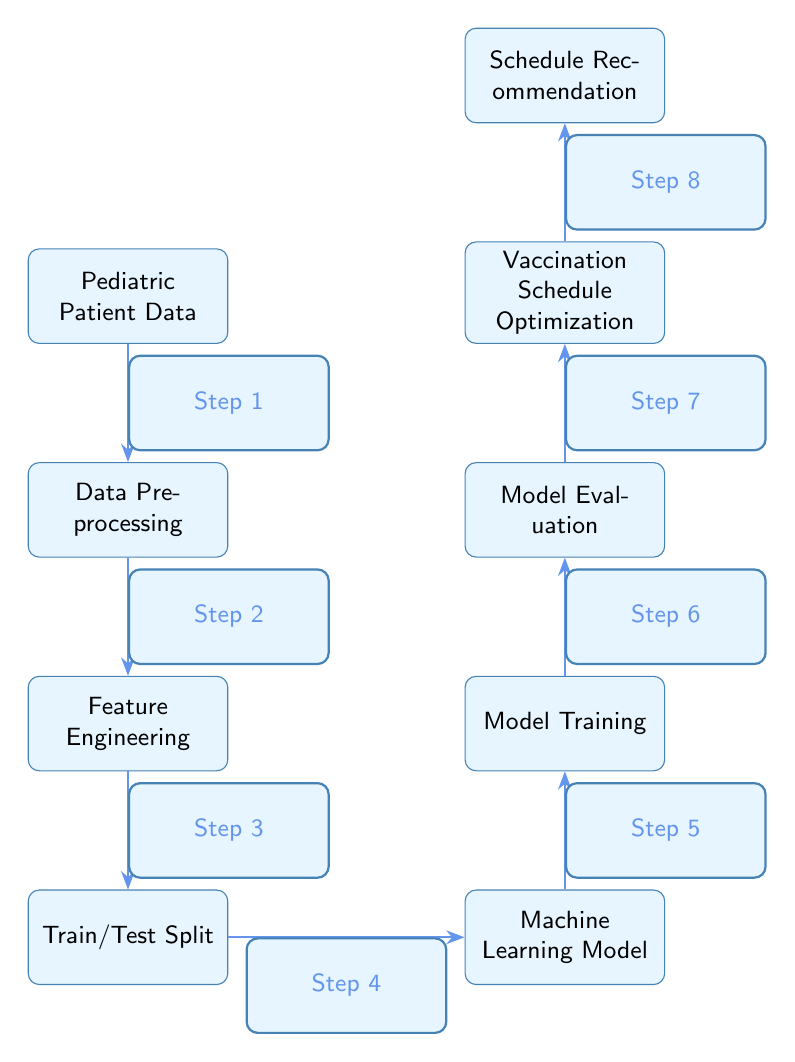What is the first step in the diagram? The first node in the diagram is "Pediatric Patient Data," which indicates the starting point of the machine learning optimization process.
Answer: Pediatric Patient Data How many nodes are present in the diagram? Counting all the distinct nodes shown in the diagram, there are a total of eight nodes, which represent various stages in the machine learning optimization of vaccination schedules.
Answer: 8 What follows after "Data Preprocessing"? The node immediately below "Data Preprocessing" is "Feature Engineering," which is the next step in the sequence as shown by the connection in the flow of the diagram.
Answer: Feature Engineering What is the last step before "Schedule Recommendation"? The step right before "Schedule Recommendation" is "Vaccination Schedule Optimization," according to the sequential flow and positioning in the diagram.
Answer: Vaccination Schedule Optimization Which step involves the actual training of the model? The node labeled "Model Training" indicates the phase where the machine learning model is trained with the prepared data, and this step comes after the Train/Test Split.
Answer: Model Training Which nodes are directly connected to "Machine Learning Model"? "Train/Test Split" is directly connected to "Machine Learning Model," and "Model Training" is the subsequent step connected above it, indicating that these two stages are integrally linked to the model's functioning.
Answer: Train/Test Split, Model Training What step comes after "Model Evaluation"? "Vaccination Schedule Optimization" is the step that follows "Model Evaluation," showing that once the model is evaluated, the process moves to the optimization stage for vaccination scheduling.
Answer: Vaccination Schedule Optimization Which is the fourth step in the diagram? The fourth step is represented by the node "Machine Learning Model," which occurs after data has been prepared, features engineered, and training/testing datasets have been split in the earlier steps.
Answer: Machine Learning Model What is the relationship between “Feature Engineering” and “Train/Test Split”? “Feature Engineering” must be completed before the “Train/Test Split” occurs, as each step is dependent on the completion of the previous one, indicating the progression in the data processing workflow.
Answer: Sequential dependency 